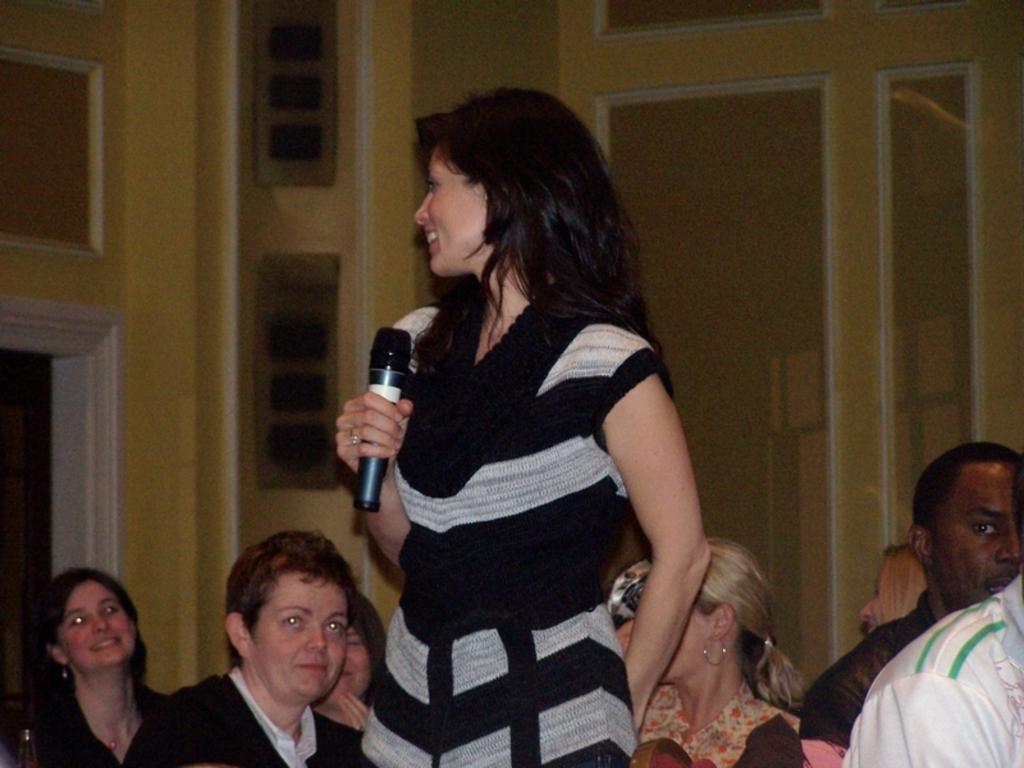How would you summarize this image in a sentence or two? In this image I can see the person standing and holding the mic. The person is wearing the white and black color dress. To the back of the person I can see the group of people wearing the different color dresses. In the back I can see the yellow color wall. 